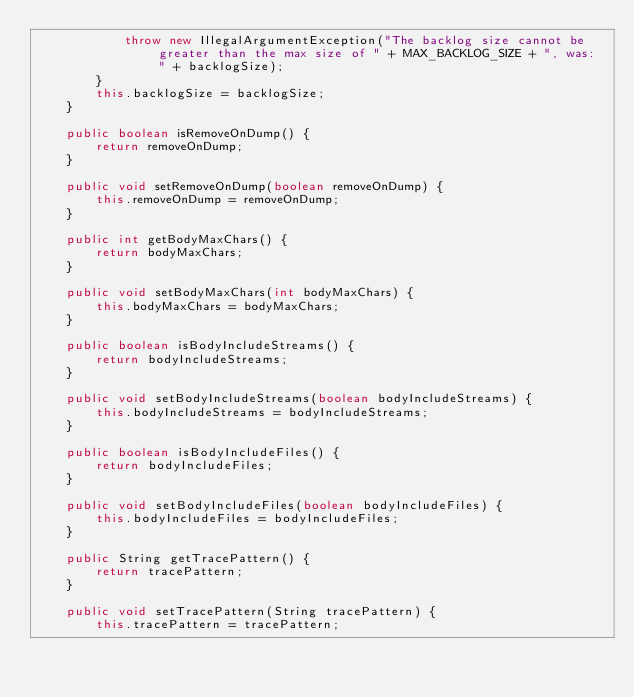Convert code to text. <code><loc_0><loc_0><loc_500><loc_500><_Java_>            throw new IllegalArgumentException("The backlog size cannot be greater than the max size of " + MAX_BACKLOG_SIZE + ", was: " + backlogSize);
        }
        this.backlogSize = backlogSize;
    }

    public boolean isRemoveOnDump() {
        return removeOnDump;
    }

    public void setRemoveOnDump(boolean removeOnDump) {
        this.removeOnDump = removeOnDump;
    }

    public int getBodyMaxChars() {
        return bodyMaxChars;
    }

    public void setBodyMaxChars(int bodyMaxChars) {
        this.bodyMaxChars = bodyMaxChars;
    }

    public boolean isBodyIncludeStreams() {
        return bodyIncludeStreams;
    }

    public void setBodyIncludeStreams(boolean bodyIncludeStreams) {
        this.bodyIncludeStreams = bodyIncludeStreams;
    }

    public boolean isBodyIncludeFiles() {
        return bodyIncludeFiles;
    }

    public void setBodyIncludeFiles(boolean bodyIncludeFiles) {
        this.bodyIncludeFiles = bodyIncludeFiles;
    }

    public String getTracePattern() {
        return tracePattern;
    }

    public void setTracePattern(String tracePattern) {
        this.tracePattern = tracePattern;</code> 